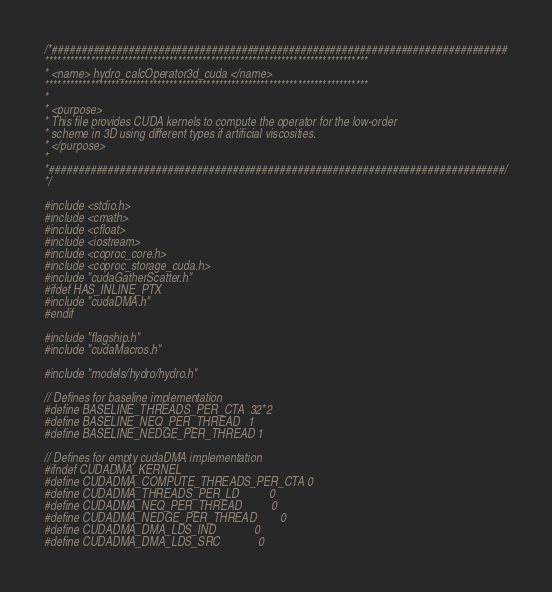Convert code to text. <code><loc_0><loc_0><loc_500><loc_500><_Cuda_>/*#############################################################################
******************************************************************************
* <name> hydro_calcOperator3d_cuda </name>
******************************************************************************
*
* <purpose>
* This file provides CUDA kernels to compute the operator for the low-order
* scheme in 3D using different types if artificial viscosities.
* </purpose>
*
*#############################################################################/
*/

#include <stdio.h>
#include <cmath>
#include <cfloat>
#include <iostream>
#include <coproc_core.h>
#include <coproc_storage_cuda.h>
#include "cudaGatherScatter.h"
#ifdef HAS_INLINE_PTX
#include "cudaDMA.h"
#endif

#include "flagship.h"
#include "cudaMacros.h"

#include "models/hydro/hydro.h"

// Defines for baseline implementation
#define BASELINE_THREADS_PER_CTA  32*2
#define BASELINE_NEQ_PER_THREAD   1
#define BASELINE_NEDGE_PER_THREAD 1

// Defines for empty cudaDMA implementation
#ifndef CUDADMA_KERNEL
#define CUDADMA_COMPUTE_THREADS_PER_CTA 0
#define CUDADMA_THREADS_PER_LD          0
#define CUDADMA_NEQ_PER_THREAD          0
#define CUDADMA_NEDGE_PER_THREAD        0
#define CUDADMA_DMA_LDS_IND             0
#define CUDADMA_DMA_LDS_SRC             0</code> 